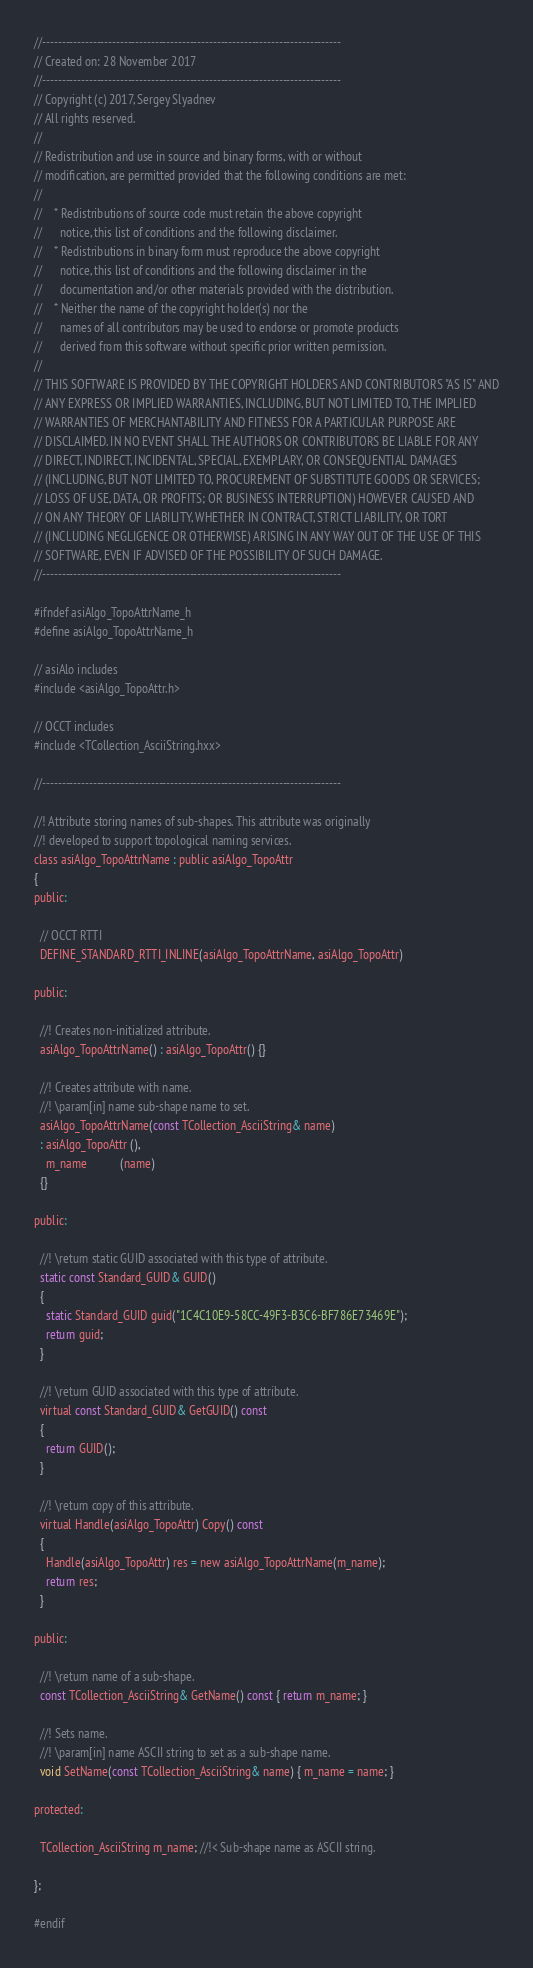<code> <loc_0><loc_0><loc_500><loc_500><_C_>//-----------------------------------------------------------------------------
// Created on: 28 November 2017
//-----------------------------------------------------------------------------
// Copyright (c) 2017, Sergey Slyadnev
// All rights reserved.
//
// Redistribution and use in source and binary forms, with or without
// modification, are permitted provided that the following conditions are met:
//
//    * Redistributions of source code must retain the above copyright
//      notice, this list of conditions and the following disclaimer.
//    * Redistributions in binary form must reproduce the above copyright
//      notice, this list of conditions and the following disclaimer in the
//      documentation and/or other materials provided with the distribution.
//    * Neither the name of the copyright holder(s) nor the
//      names of all contributors may be used to endorse or promote products
//      derived from this software without specific prior written permission.
//
// THIS SOFTWARE IS PROVIDED BY THE COPYRIGHT HOLDERS AND CONTRIBUTORS "AS IS" AND
// ANY EXPRESS OR IMPLIED WARRANTIES, INCLUDING, BUT NOT LIMITED TO, THE IMPLIED
// WARRANTIES OF MERCHANTABILITY AND FITNESS FOR A PARTICULAR PURPOSE ARE
// DISCLAIMED. IN NO EVENT SHALL THE AUTHORS OR CONTRIBUTORS BE LIABLE FOR ANY
// DIRECT, INDIRECT, INCIDENTAL, SPECIAL, EXEMPLARY, OR CONSEQUENTIAL DAMAGES
// (INCLUDING, BUT NOT LIMITED TO, PROCUREMENT OF SUBSTITUTE GOODS OR SERVICES;
// LOSS OF USE, DATA, OR PROFITS; OR BUSINESS INTERRUPTION) HOWEVER CAUSED AND
// ON ANY THEORY OF LIABILITY, WHETHER IN CONTRACT, STRICT LIABILITY, OR TORT
// (INCLUDING NEGLIGENCE OR OTHERWISE) ARISING IN ANY WAY OUT OF THE USE OF THIS
// SOFTWARE, EVEN IF ADVISED OF THE POSSIBILITY OF SUCH DAMAGE.
//-----------------------------------------------------------------------------

#ifndef asiAlgo_TopoAttrName_h
#define asiAlgo_TopoAttrName_h

// asiAlo includes
#include <asiAlgo_TopoAttr.h>

// OCCT includes
#include <TCollection_AsciiString.hxx>

//-----------------------------------------------------------------------------

//! Attribute storing names of sub-shapes. This attribute was originally
//! developed to support topological naming services.
class asiAlgo_TopoAttrName : public asiAlgo_TopoAttr
{
public:

  // OCCT RTTI
  DEFINE_STANDARD_RTTI_INLINE(asiAlgo_TopoAttrName, asiAlgo_TopoAttr)

public:

  //! Creates non-initialized attribute.
  asiAlgo_TopoAttrName() : asiAlgo_TopoAttr() {}

  //! Creates attribute with name.
  //! \param[in] name sub-shape name to set.
  asiAlgo_TopoAttrName(const TCollection_AsciiString& name)
  : asiAlgo_TopoAttr (),
    m_name           (name)
  {}

public:

  //! \return static GUID associated with this type of attribute.
  static const Standard_GUID& GUID()
  {
    static Standard_GUID guid("1C4C10E9-58CC-49F3-B3C6-BF786E73469E");
    return guid;
  }

  //! \return GUID associated with this type of attribute.
  virtual const Standard_GUID& GetGUID() const
  {
    return GUID();
  }

  //! \return copy of this attribute.
  virtual Handle(asiAlgo_TopoAttr) Copy() const
  {
    Handle(asiAlgo_TopoAttr) res = new asiAlgo_TopoAttrName(m_name);
    return res;
  }

public:

  //! \return name of a sub-shape.
  const TCollection_AsciiString& GetName() const { return m_name; }

  //! Sets name.
  //! \param[in] name ASCII string to set as a sub-shape name.
  void SetName(const TCollection_AsciiString& name) { m_name = name; }

protected:

  TCollection_AsciiString m_name; //!< Sub-shape name as ASCII string.

};

#endif
</code> 